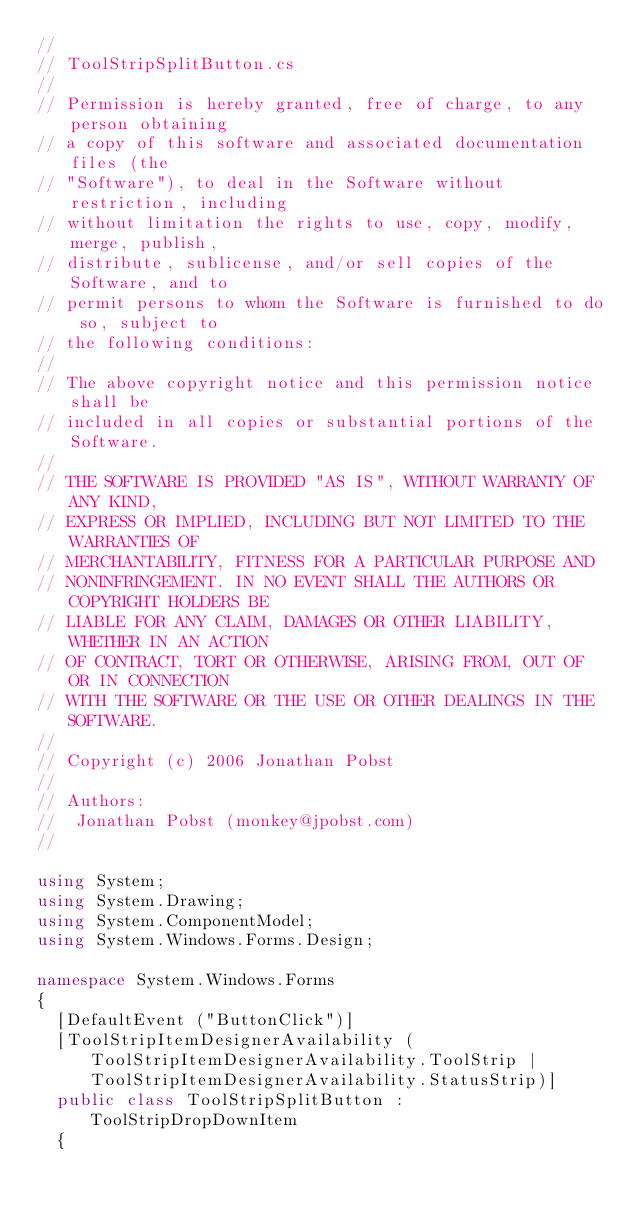Convert code to text. <code><loc_0><loc_0><loc_500><loc_500><_C#_>//
// ToolStripSplitButton.cs
//
// Permission is hereby granted, free of charge, to any person obtaining
// a copy of this software and associated documentation files (the
// "Software"), to deal in the Software without restriction, including
// without limitation the rights to use, copy, modify, merge, publish,
// distribute, sublicense, and/or sell copies of the Software, and to
// permit persons to whom the Software is furnished to do so, subject to
// the following conditions:
// 
// The above copyright notice and this permission notice shall be
// included in all copies or substantial portions of the Software.
// 
// THE SOFTWARE IS PROVIDED "AS IS", WITHOUT WARRANTY OF ANY KIND,
// EXPRESS OR IMPLIED, INCLUDING BUT NOT LIMITED TO THE WARRANTIES OF
// MERCHANTABILITY, FITNESS FOR A PARTICULAR PURPOSE AND
// NONINFRINGEMENT. IN NO EVENT SHALL THE AUTHORS OR COPYRIGHT HOLDERS BE
// LIABLE FOR ANY CLAIM, DAMAGES OR OTHER LIABILITY, WHETHER IN AN ACTION
// OF CONTRACT, TORT OR OTHERWISE, ARISING FROM, OUT OF OR IN CONNECTION
// WITH THE SOFTWARE OR THE USE OR OTHER DEALINGS IN THE SOFTWARE.
//
// Copyright (c) 2006 Jonathan Pobst
//
// Authors:
//	Jonathan Pobst (monkey@jpobst.com)
//

using System;
using System.Drawing;
using System.ComponentModel;
using System.Windows.Forms.Design;

namespace System.Windows.Forms
{
	[DefaultEvent ("ButtonClick")]
	[ToolStripItemDesignerAvailability (ToolStripItemDesignerAvailability.ToolStrip | ToolStripItemDesignerAvailability.StatusStrip)]
	public class ToolStripSplitButton : ToolStripDropDownItem
	{</code> 